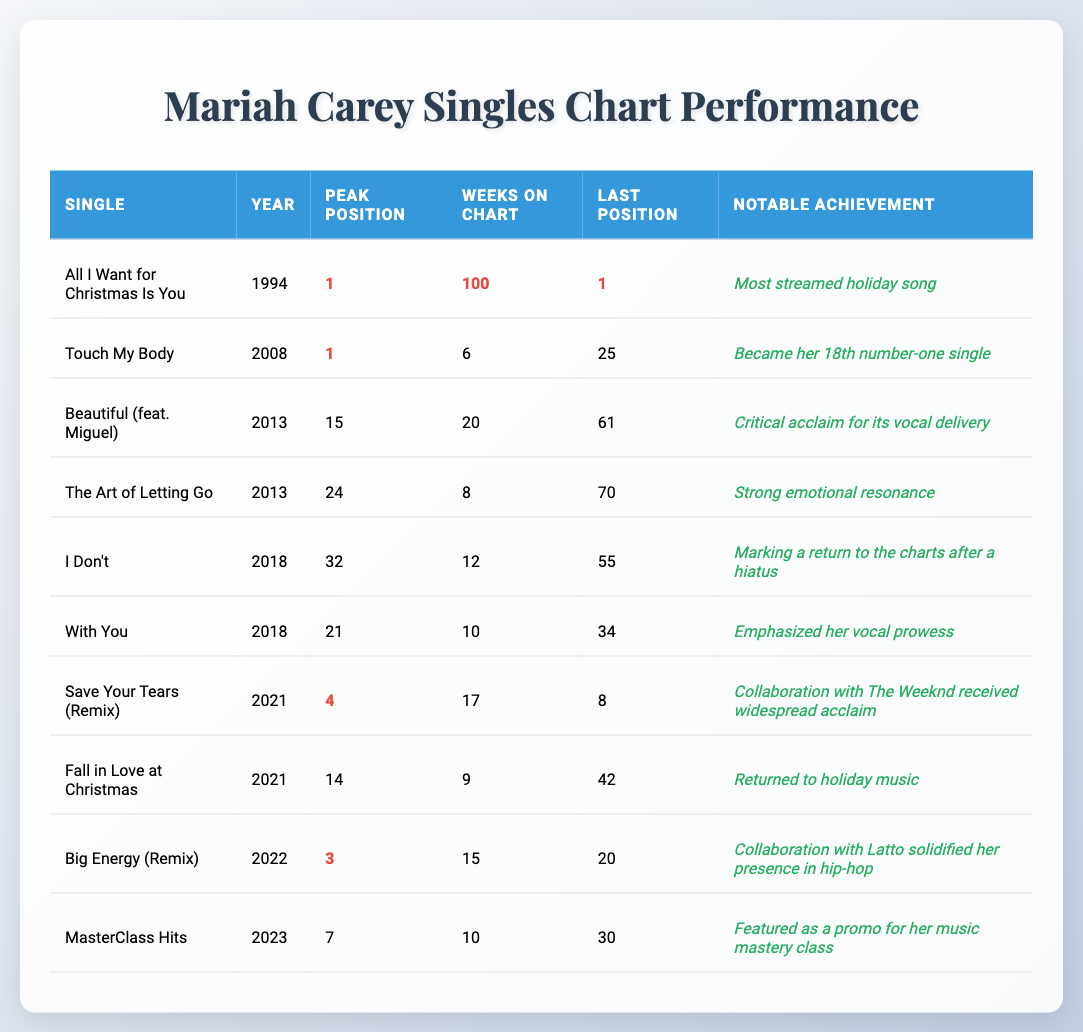What single has the longest weeks on the chart? "All I Want for Christmas Is You" has the highest number of weeks on the chart, with a total of 100 weeks.
Answer: All I Want for Christmas Is You How many singles reached number one? The singles that reached number one are "All I Want for Christmas Is You" and "Touch My Body," making it a total of two singles.
Answer: 2 What is the chart position of "Save Your Tears (Remix)"? "Save Your Tears (Remix)" peaked at position 4 in the chart rankings.
Answer: 4 Which single had the most recent release year? The most recent single listed is "MasterClass Hits," released in 2023.
Answer: MasterClass Hits Which single has the highest peak position and weeks on chart combined? "All I Want for Christmas Is You" has the highest values for both peak position (1) and weeks on chart (100), giving a combined total of 101.
Answer: All I Want for Christmas Is You Is there any single from 2021 that reached the top 10? Yes, "Save Your Tears (Remix)" reached position 4 and was a single from 2021, thus it is confirmed as hitting the top 10.
Answer: Yes What is the average peak position of singles released in 2018? The singles from 2018 are "I Don't" (32) and "With You" (21). The average peak position is (32 + 21) / 2 = 26.5.
Answer: 26.5 Which single had a notable achievement highlighting a return to holiday music? "Fall in Love at Christmas" noted its return to holiday music, which aligns with its seasonal theme.
Answer: Fall in Love at Christmas What is the last chart position for "Big Energy (Remix)"? The last chart position for "Big Energy (Remix)" is noted as 20.
Answer: 20 Which single had a notable achievement for emphasizing Mariah's vocal prowess? The single "With You" emphasized her vocal prowess as its notable achievement.
Answer: With You 